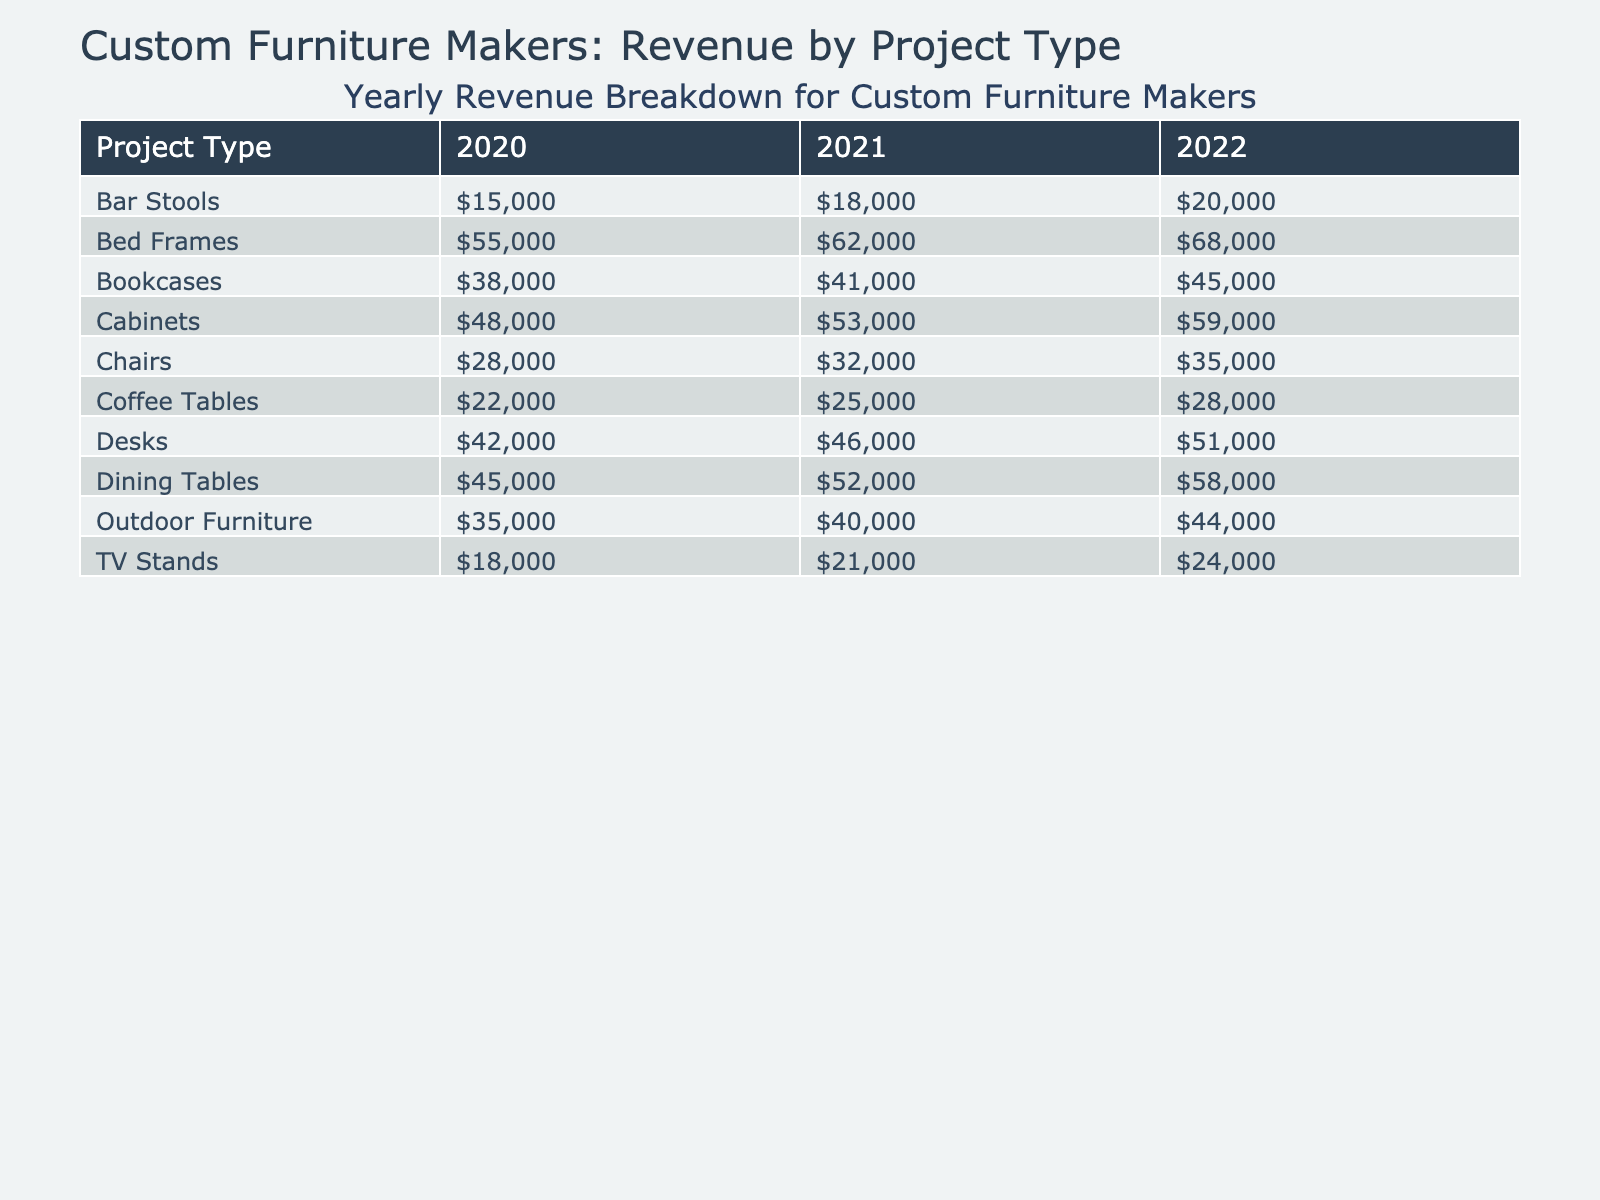What was the revenue from Dining Tables in 2022? In the table, under the Dining Tables row and the year 2022, the revenue is listed as 58,000.
Answer: 58,000 Which project type had the highest revenue in 2021? Looking at the year 2021, we can compare the revenues for each project type. Bed Frames had the highest revenue of 62,000, while the next highest was Dining Tables at 52,000.
Answer: Bed Frames What is the total revenue for Chairs from 2020 to 2022? The total revenue can be calculated by adding the values for Chairs in 2020 (28,000), 2021 (32,000), and 2022 (35,000). The sum is 28,000 + 32,000 + 35,000 = 95,000.
Answer: 95,000 Did the revenue from Coffee Tables increase every year from 2020 to 2022? Checking the values for Coffee Tables, we see they were 22,000 in 2020, 25,000 in 2021, and 28,000 in 2022. Since all the numbers are increasing, the answer is yes.
Answer: Yes What was the average revenue for Outdoor Furniture over the three years? To find the average, we add the revenues for Outdoor Furniture for 2020 (35,000), 2021 (40,000), and 2022 (44,000) which gives us 35,000 + 40,000 + 44,000 = 119,000. Dividing this total by the number of years gives us 119,000 / 3 = 39,667.
Answer: 39,667 Which project types had revenues below 30,000 in 2020? Looking at the table for 2020, the only project types with revenues below 30,000 are TV Stands (18,000) and Bar Stools (15,000).
Answer: TV Stands and Bar Stools What is the difference in revenue for Bed Frames between 2020 and 2022? To find the difference, we subtract the revenue for Bed Frames in 2020 (55,000) from that in 2022 (68,000). The calculation is 68,000 - 55,000 = 13,000.
Answer: 13,000 Is it true that Cabinets have consistently increased in revenue each year? By examining the Cabinet revenues, we see they were 48,000 in 2020, 53,000 in 2021, and 59,000 in 2022. Since each value is higher than the previous year, the statement is true.
Answer: True What was the total revenue from all project types in 2022? We need to sum the revenue for all project types in 2022: 58,000 (Dining Tables) + 35,000 (Chairs) + 45,000 (Bookcases) + 68,000 (Bed Frames) + 28,000 (Coffee Tables) + 59,000 (Cabinets) + 51,000 (Desks) + 44,000 (Outdoor Furniture) + 24,000 (TV Stands) + 20,000 (Bar Stools) = 392,000.
Answer: 392,000 Which project type showed the least growth in revenue from 2020 to 2022? We can calculate the growth for each project type from 2020 to 2022 and find the difference. The project type with the least growth is Bar Stools, which grew from 15,000 in 2020 to 20,000 in 2022, a growth of only 5,000. Others had higher growths.
Answer: Bar Stools 